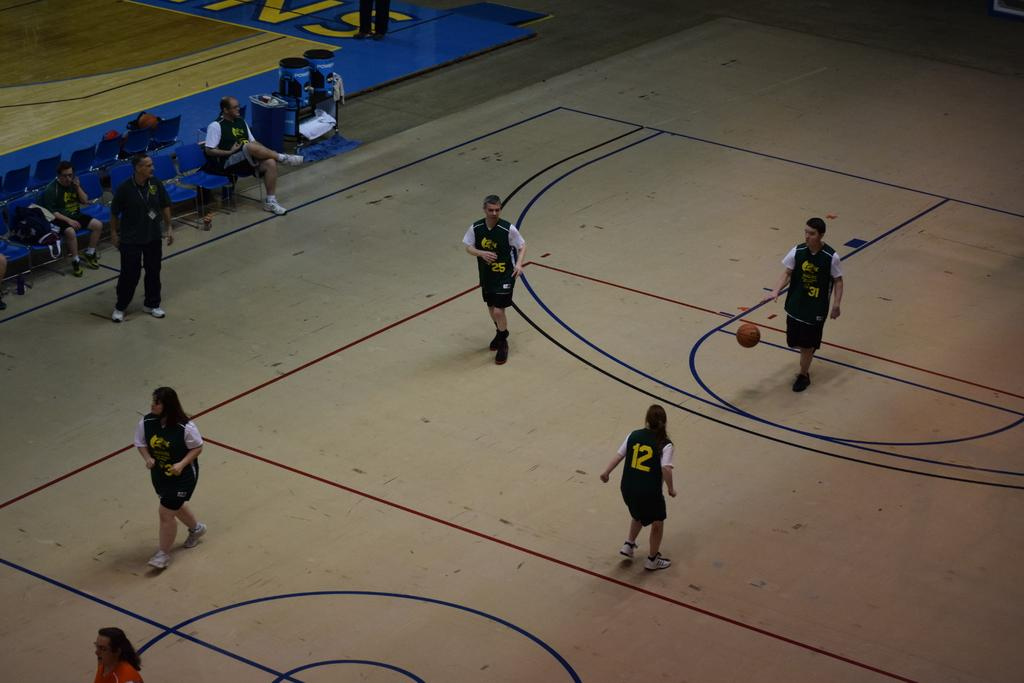<image>
Summarize the visual content of the image. A basketball game and player 31 has the ball. 